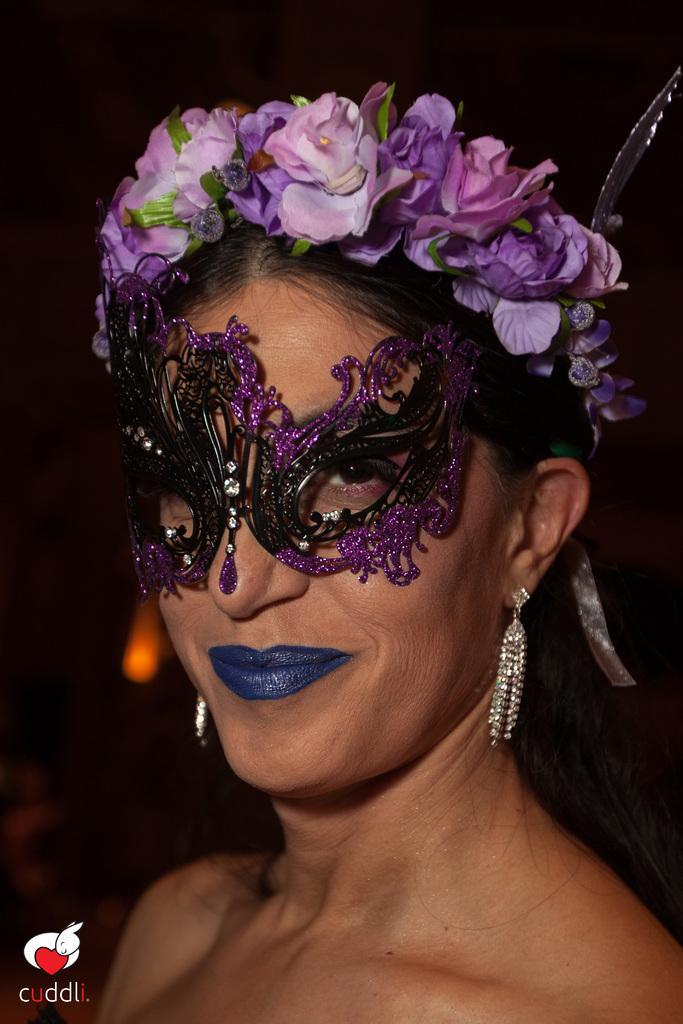Can you describe this image briefly? In this image, we can see a woman is smiling and wearing a mask and crown. Left side bottom, we can see some icon and text. 